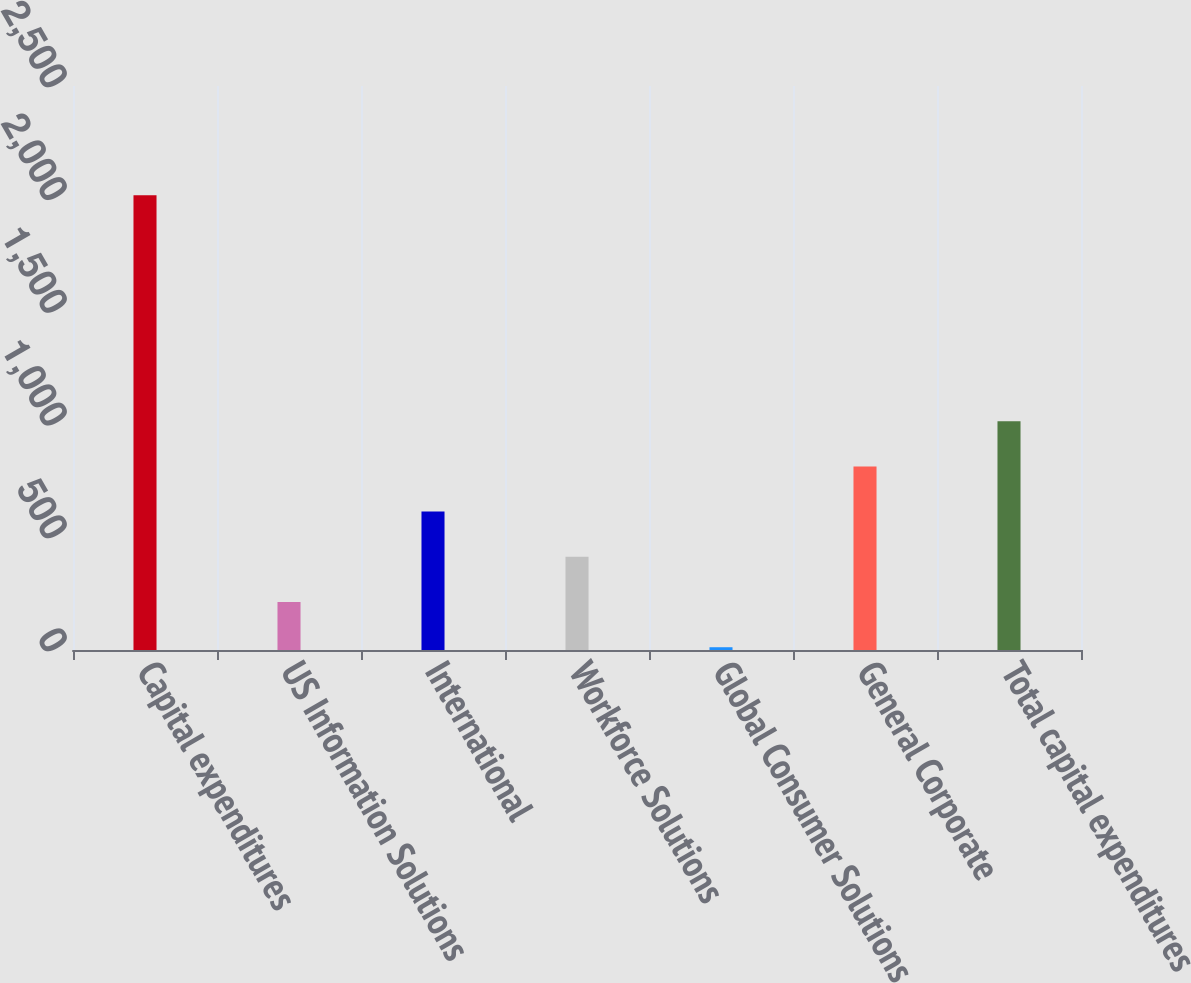<chart> <loc_0><loc_0><loc_500><loc_500><bar_chart><fcel>Capital expenditures<fcel>US Information Solutions<fcel>International<fcel>Workforce Solutions<fcel>Global Consumer Solutions<fcel>General Corporate<fcel>Total capital expenditures<nl><fcel>2016<fcel>212.67<fcel>613.41<fcel>413.04<fcel>12.3<fcel>813.78<fcel>1014.15<nl></chart> 